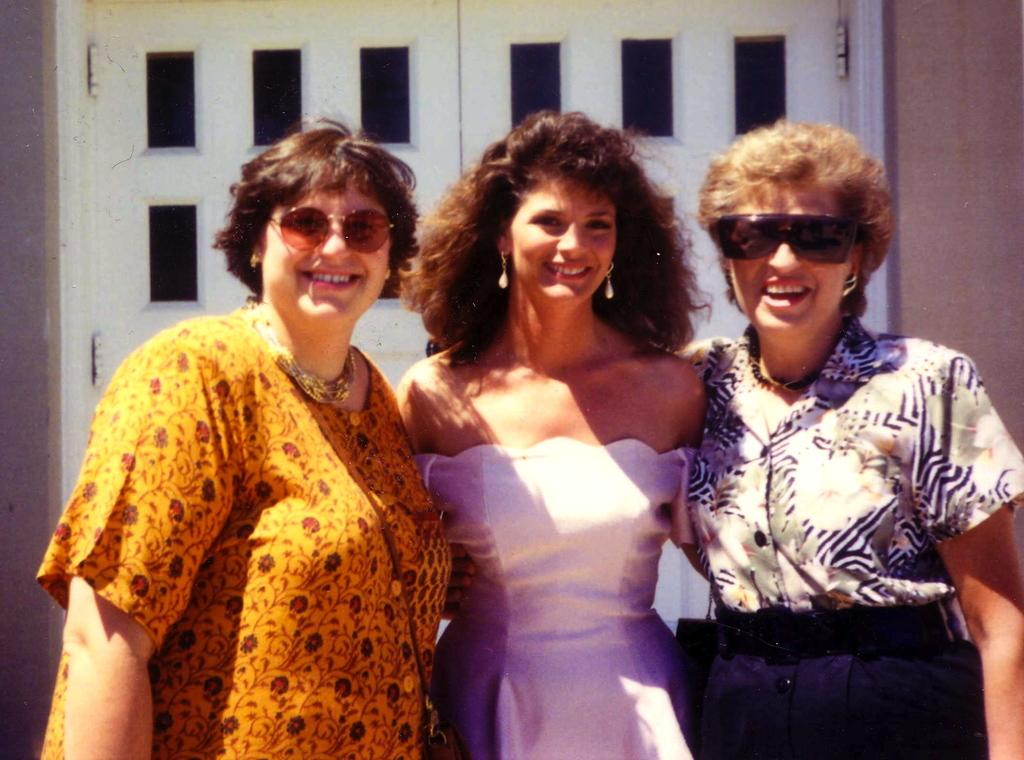How many women are in the image? There are three women in the image. What are the women doing in the image? The women are standing and giving a pose for the picture. What expressions do the women have in the image? The women are smiling in the image. What can be seen in the background of the image? There is a wall and doors visible in the background of the image. How many brothers do the women have in the image? There is no information about the women's brothers in the image. 